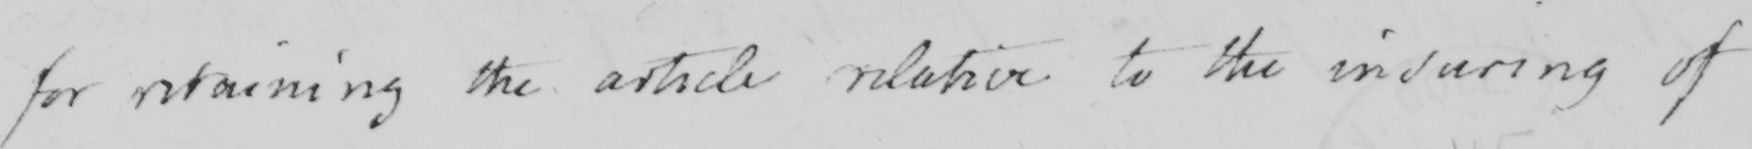What text is written in this handwritten line? For retaining the article relative to the insuring of 